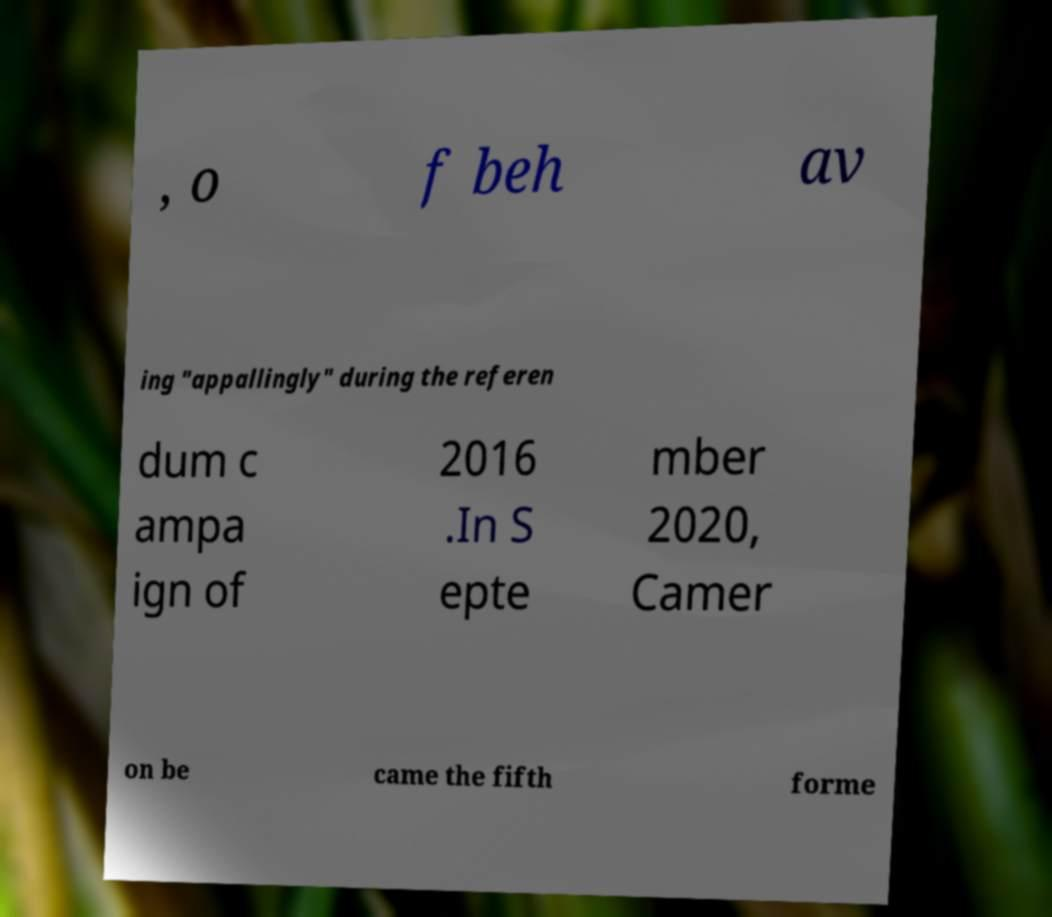For documentation purposes, I need the text within this image transcribed. Could you provide that? , o f beh av ing "appallingly" during the referen dum c ampa ign of 2016 .In S epte mber 2020, Camer on be came the fifth forme 